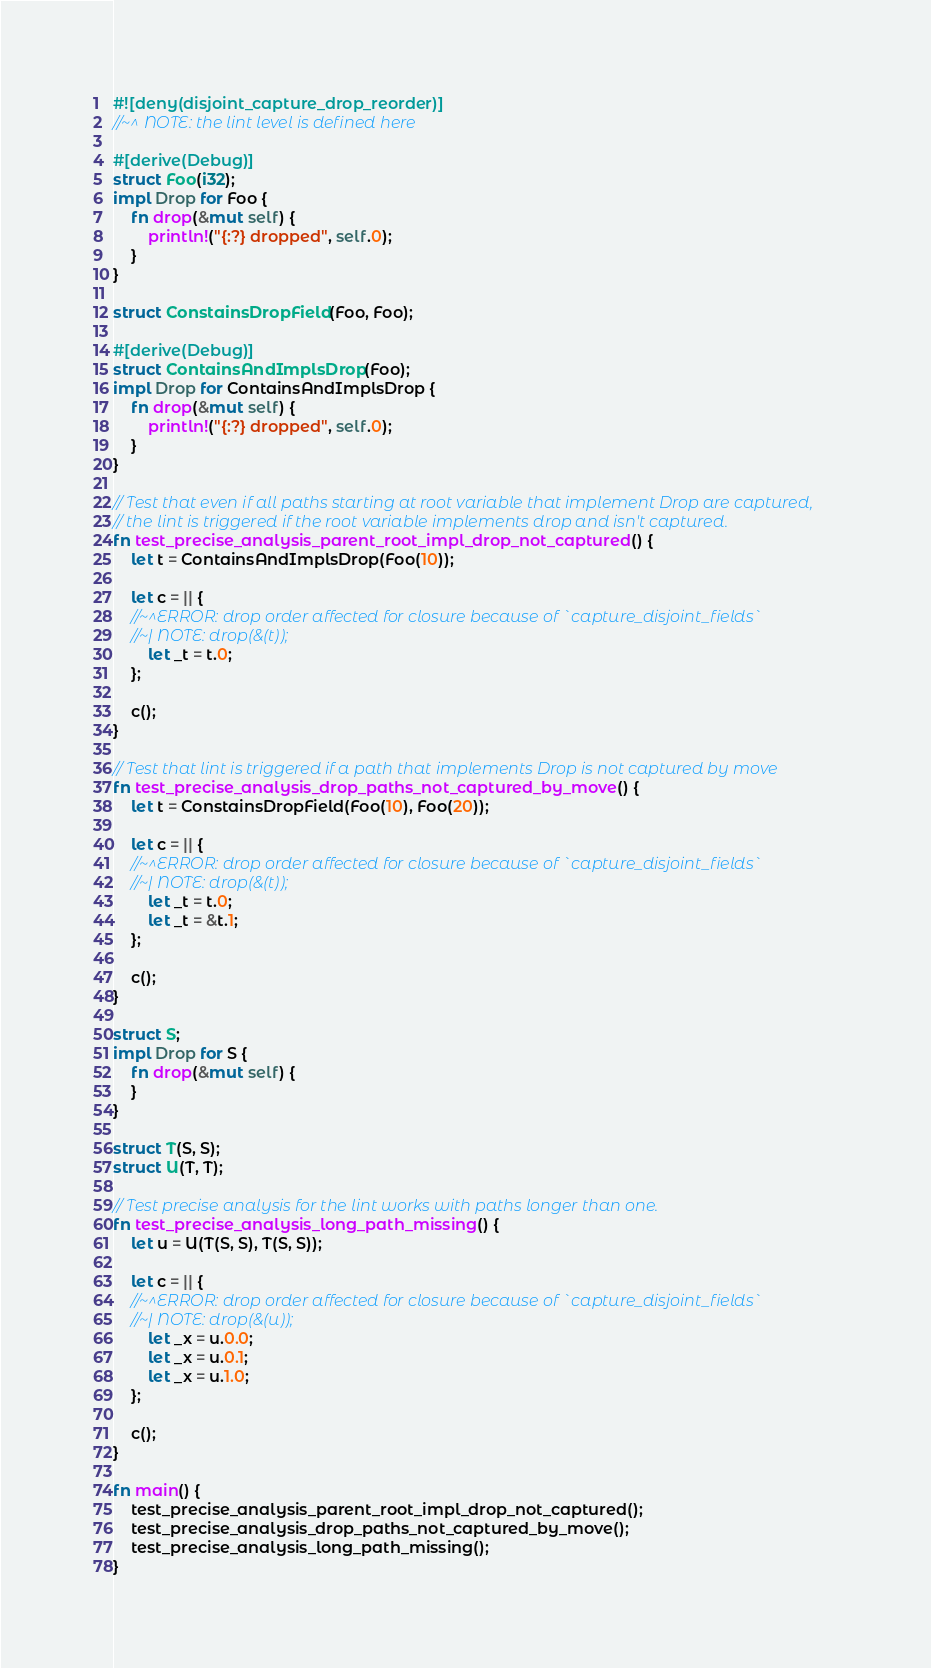<code> <loc_0><loc_0><loc_500><loc_500><_Rust_>#![deny(disjoint_capture_drop_reorder)]
//~^ NOTE: the lint level is defined here

#[derive(Debug)]
struct Foo(i32);
impl Drop for Foo {
    fn drop(&mut self) {
        println!("{:?} dropped", self.0);
    }
}

struct ConstainsDropField(Foo, Foo);

#[derive(Debug)]
struct ContainsAndImplsDrop(Foo);
impl Drop for ContainsAndImplsDrop {
    fn drop(&mut self) {
        println!("{:?} dropped", self.0);
    }
}

// Test that even if all paths starting at root variable that implement Drop are captured,
// the lint is triggered if the root variable implements drop and isn't captured.
fn test_precise_analysis_parent_root_impl_drop_not_captured() {
    let t = ContainsAndImplsDrop(Foo(10));

    let c = || {
    //~^ERROR: drop order affected for closure because of `capture_disjoint_fields`
    //~| NOTE: drop(&(t));
        let _t = t.0;
    };

    c();
}

// Test that lint is triggered if a path that implements Drop is not captured by move
fn test_precise_analysis_drop_paths_not_captured_by_move() {
    let t = ConstainsDropField(Foo(10), Foo(20));

    let c = || {
    //~^ERROR: drop order affected for closure because of `capture_disjoint_fields`
    //~| NOTE: drop(&(t));
        let _t = t.0;
        let _t = &t.1;
    };

    c();
}

struct S;
impl Drop for S {
    fn drop(&mut self) {
    }
}

struct T(S, S);
struct U(T, T);

// Test precise analysis for the lint works with paths longer than one.
fn test_precise_analysis_long_path_missing() {
    let u = U(T(S, S), T(S, S));

    let c = || {
    //~^ERROR: drop order affected for closure because of `capture_disjoint_fields`
    //~| NOTE: drop(&(u));
        let _x = u.0.0;
        let _x = u.0.1;
        let _x = u.1.0;
    };

    c();
}

fn main() {
    test_precise_analysis_parent_root_impl_drop_not_captured();
    test_precise_analysis_drop_paths_not_captured_by_move();
    test_precise_analysis_long_path_missing();
}
</code> 